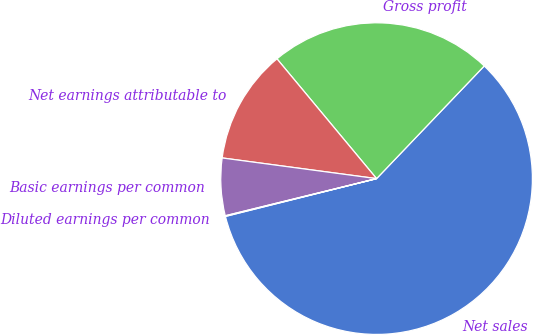<chart> <loc_0><loc_0><loc_500><loc_500><pie_chart><fcel>Net sales<fcel>Gross profit<fcel>Net earnings attributable to<fcel>Basic earnings per common<fcel>Diluted earnings per common<nl><fcel>58.96%<fcel>23.18%<fcel>11.84%<fcel>5.95%<fcel>0.07%<nl></chart> 